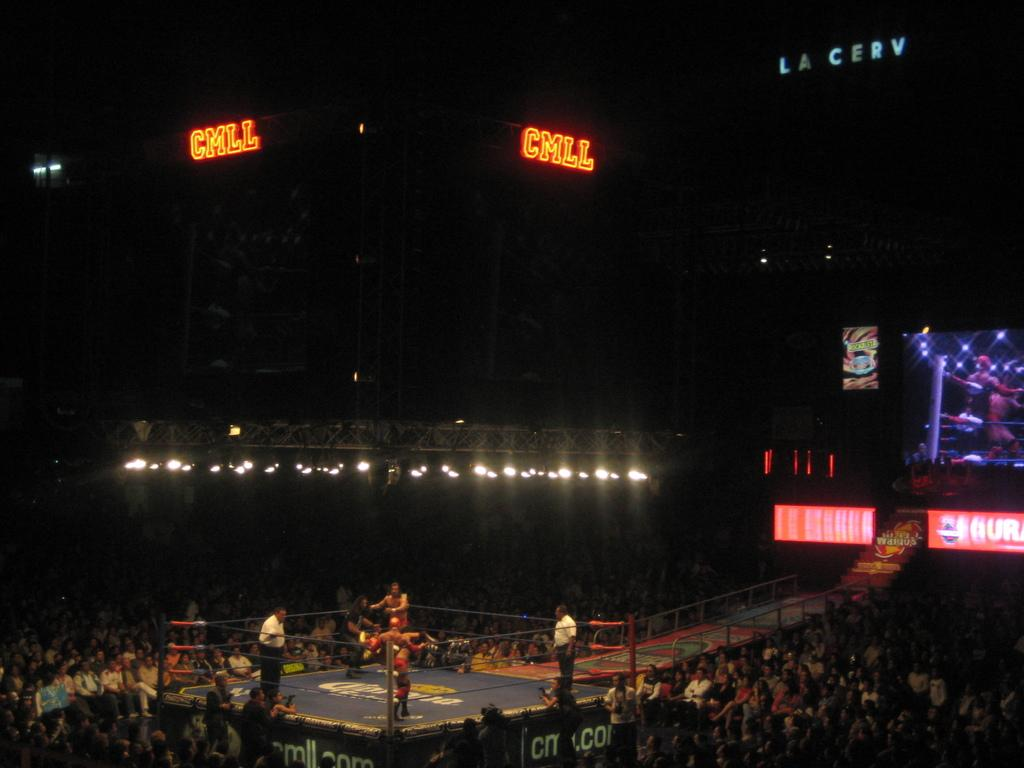Provide a one-sentence caption for the provided image. the letters cmll that are above the ring. 